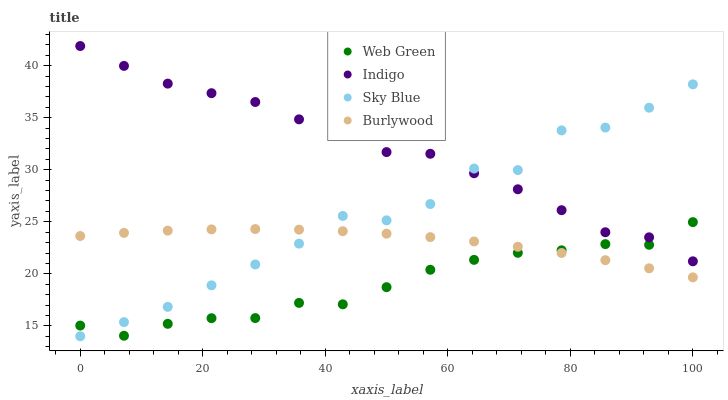Does Web Green have the minimum area under the curve?
Answer yes or no. Yes. Does Indigo have the maximum area under the curve?
Answer yes or no. Yes. Does Sky Blue have the minimum area under the curve?
Answer yes or no. No. Does Sky Blue have the maximum area under the curve?
Answer yes or no. No. Is Burlywood the smoothest?
Answer yes or no. Yes. Is Sky Blue the roughest?
Answer yes or no. Yes. Is Indigo the smoothest?
Answer yes or no. No. Is Indigo the roughest?
Answer yes or no. No. Does Sky Blue have the lowest value?
Answer yes or no. Yes. Does Indigo have the lowest value?
Answer yes or no. No. Does Indigo have the highest value?
Answer yes or no. Yes. Does Sky Blue have the highest value?
Answer yes or no. No. Is Burlywood less than Indigo?
Answer yes or no. Yes. Is Indigo greater than Burlywood?
Answer yes or no. Yes. Does Sky Blue intersect Burlywood?
Answer yes or no. Yes. Is Sky Blue less than Burlywood?
Answer yes or no. No. Is Sky Blue greater than Burlywood?
Answer yes or no. No. Does Burlywood intersect Indigo?
Answer yes or no. No. 